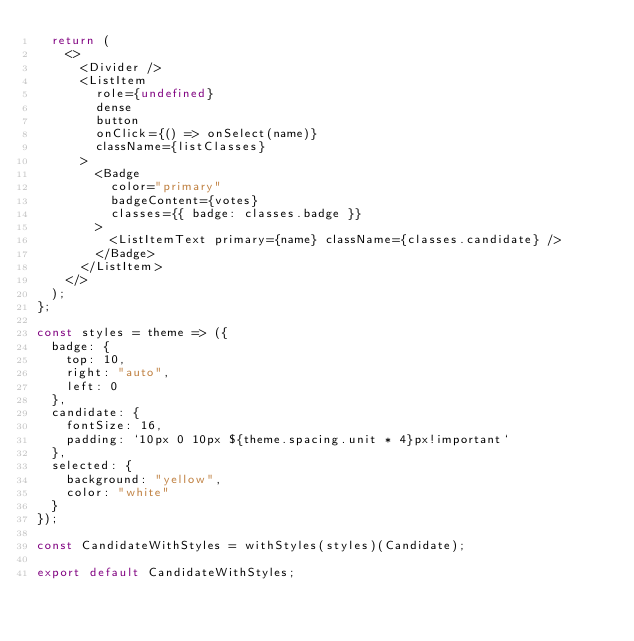Convert code to text. <code><loc_0><loc_0><loc_500><loc_500><_JavaScript_>  return (
    <>
      <Divider />
      <ListItem
        role={undefined}
        dense
        button
        onClick={() => onSelect(name)}
        className={listClasses}
      >
        <Badge
          color="primary"
          badgeContent={votes}
          classes={{ badge: classes.badge }}
        >
          <ListItemText primary={name} className={classes.candidate} />
        </Badge>
      </ListItem>
    </>
  );
};

const styles = theme => ({
  badge: {
    top: 10,
    right: "auto",
    left: 0
  },
  candidate: {
    fontSize: 16,
    padding: `10px 0 10px ${theme.spacing.unit * 4}px!important`
  },
  selected: {
    background: "yellow",
    color: "white"
  }
});

const CandidateWithStyles = withStyles(styles)(Candidate);

export default CandidateWithStyles;
</code> 